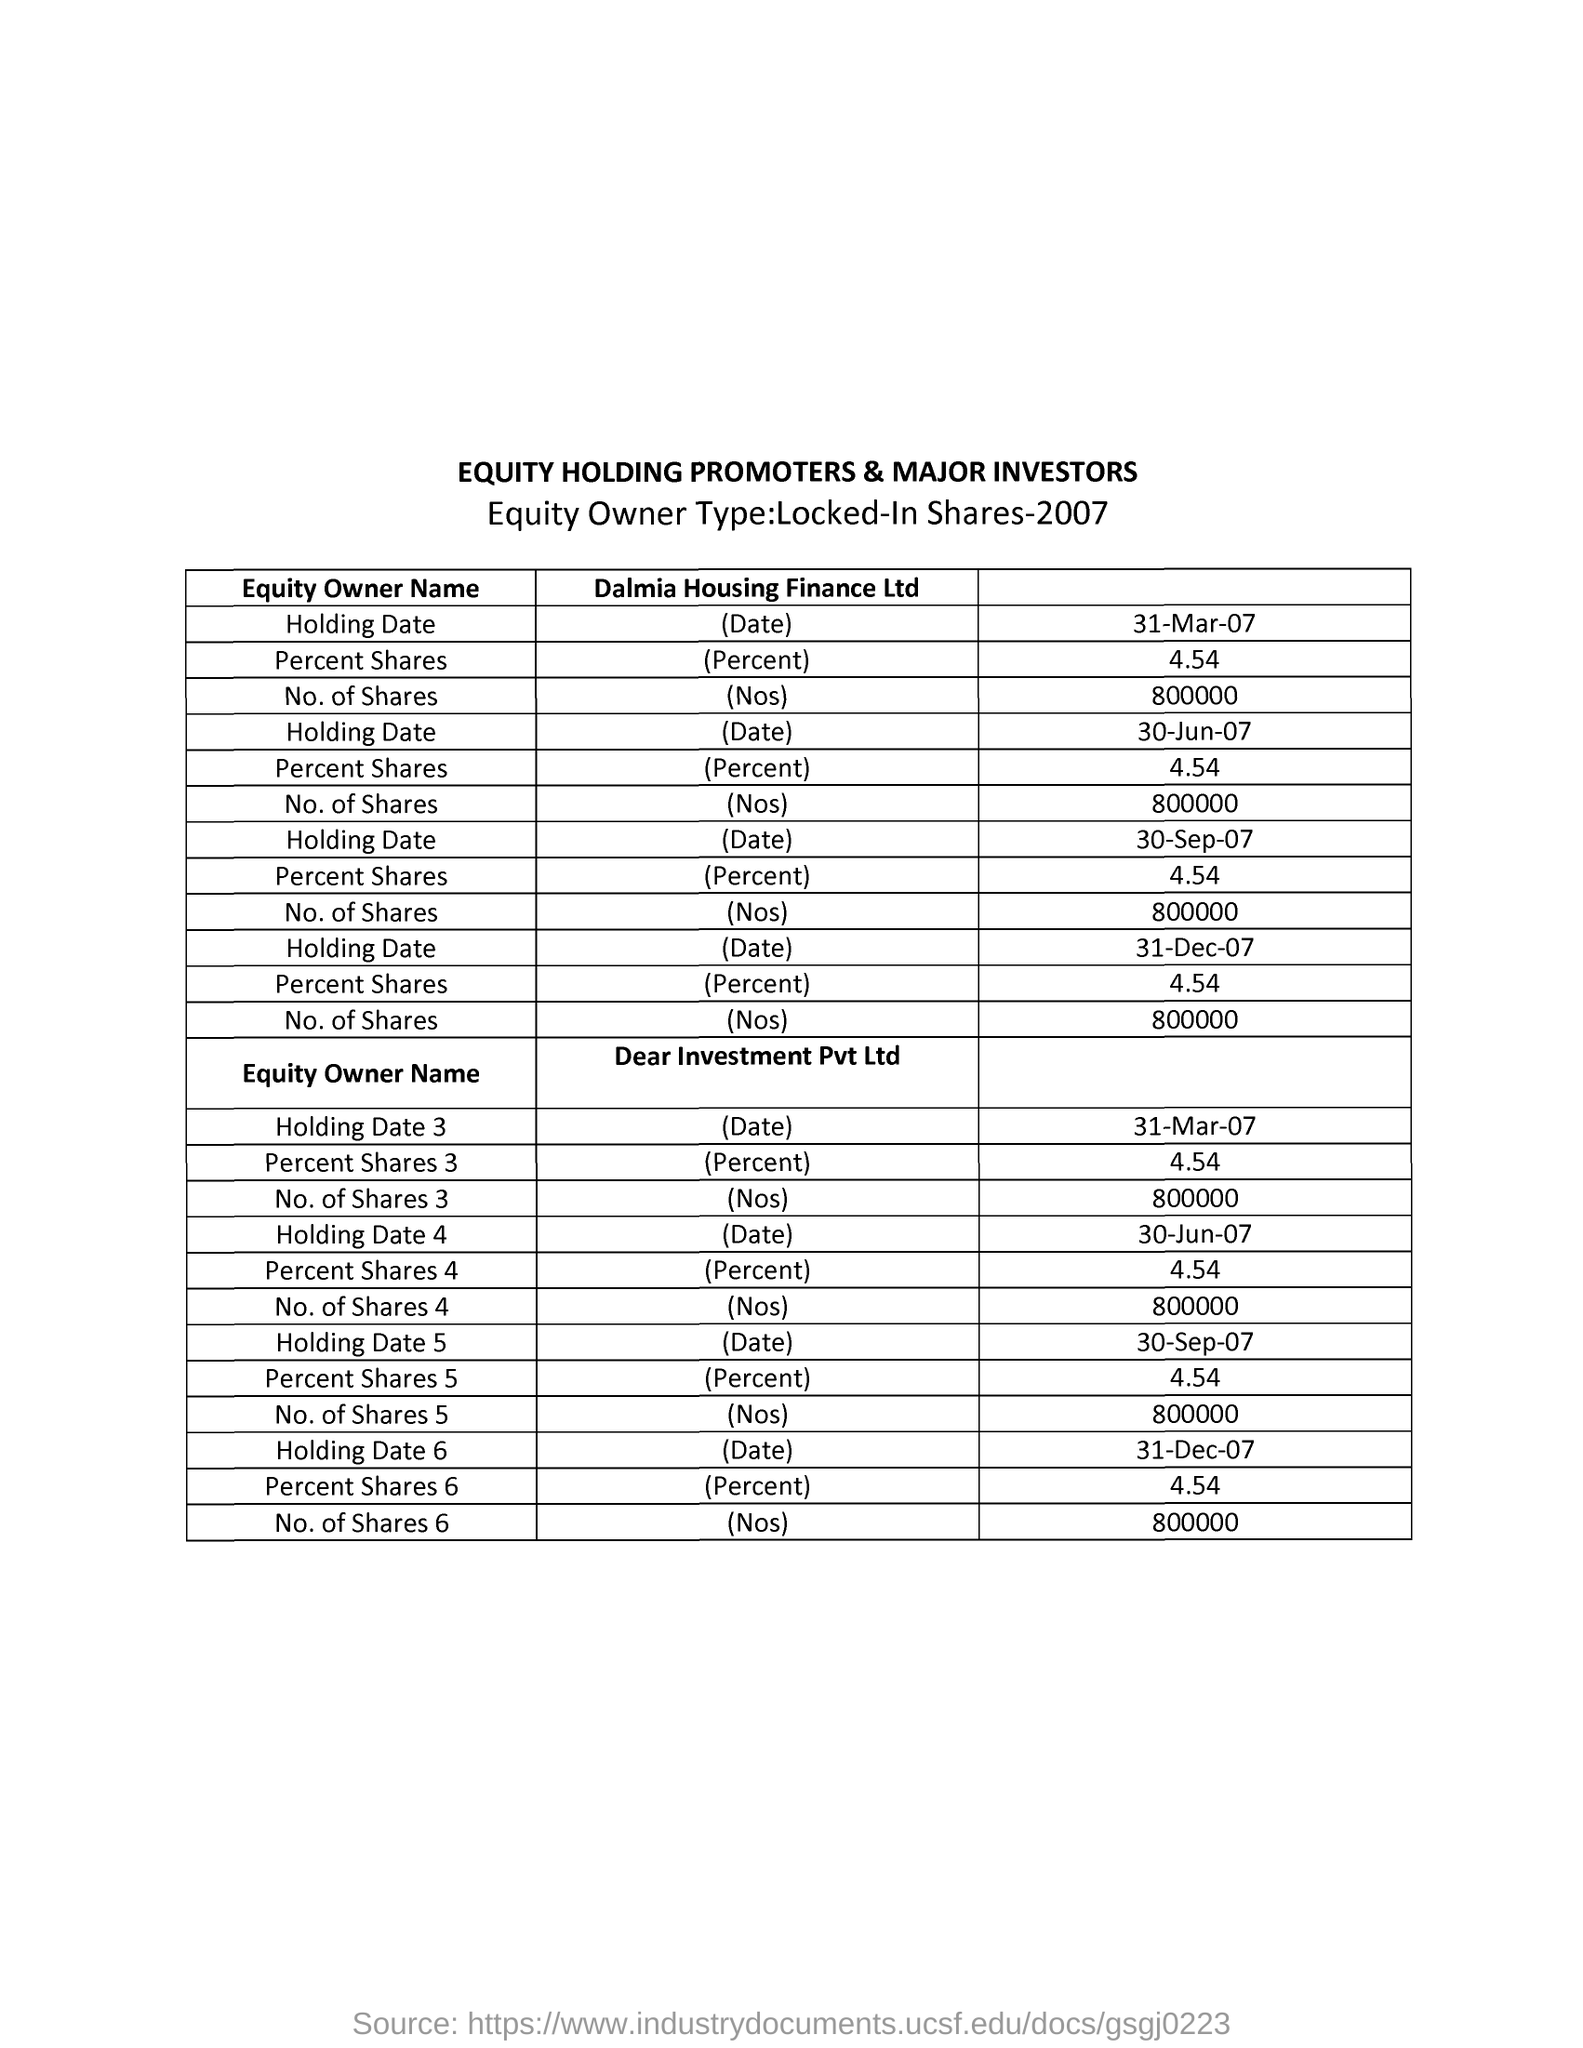Identify some key points in this picture. The document is titled "EQUITY HOLDING PROMOTERS & MAJOR INVESTORS...". 